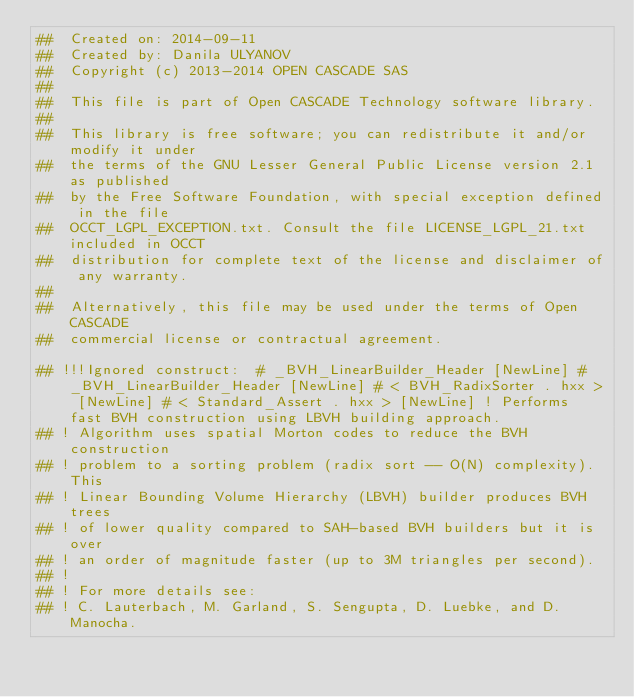Convert code to text. <code><loc_0><loc_0><loc_500><loc_500><_Nim_>##  Created on: 2014-09-11
##  Created by: Danila ULYANOV
##  Copyright (c) 2013-2014 OPEN CASCADE SAS
##
##  This file is part of Open CASCADE Technology software library.
##
##  This library is free software; you can redistribute it and/or modify it under
##  the terms of the GNU Lesser General Public License version 2.1 as published
##  by the Free Software Foundation, with special exception defined in the file
##  OCCT_LGPL_EXCEPTION.txt. Consult the file LICENSE_LGPL_21.txt included in OCCT
##  distribution for complete text of the license and disclaimer of any warranty.
##
##  Alternatively, this file may be used under the terms of Open CASCADE
##  commercial license or contractual agreement.

## !!!Ignored construct:  # _BVH_LinearBuilder_Header [NewLine] # _BVH_LinearBuilder_Header [NewLine] # < BVH_RadixSorter . hxx > [NewLine] # < Standard_Assert . hxx > [NewLine] ! Performs fast BVH construction using LBVH building approach.
## ! Algorithm uses spatial Morton codes to reduce the BVH construction
## ! problem to a sorting problem (radix sort -- O(N) complexity). This
## ! Linear Bounding Volume Hierarchy (LBVH) builder produces BVH trees
## ! of lower quality compared to SAH-based BVH builders but it is over
## ! an order of magnitude faster (up to 3M triangles per second).
## !
## ! For more details see:
## ! C. Lauterbach, M. Garland, S. Sengupta, D. Luebke, and D. Manocha.</code> 